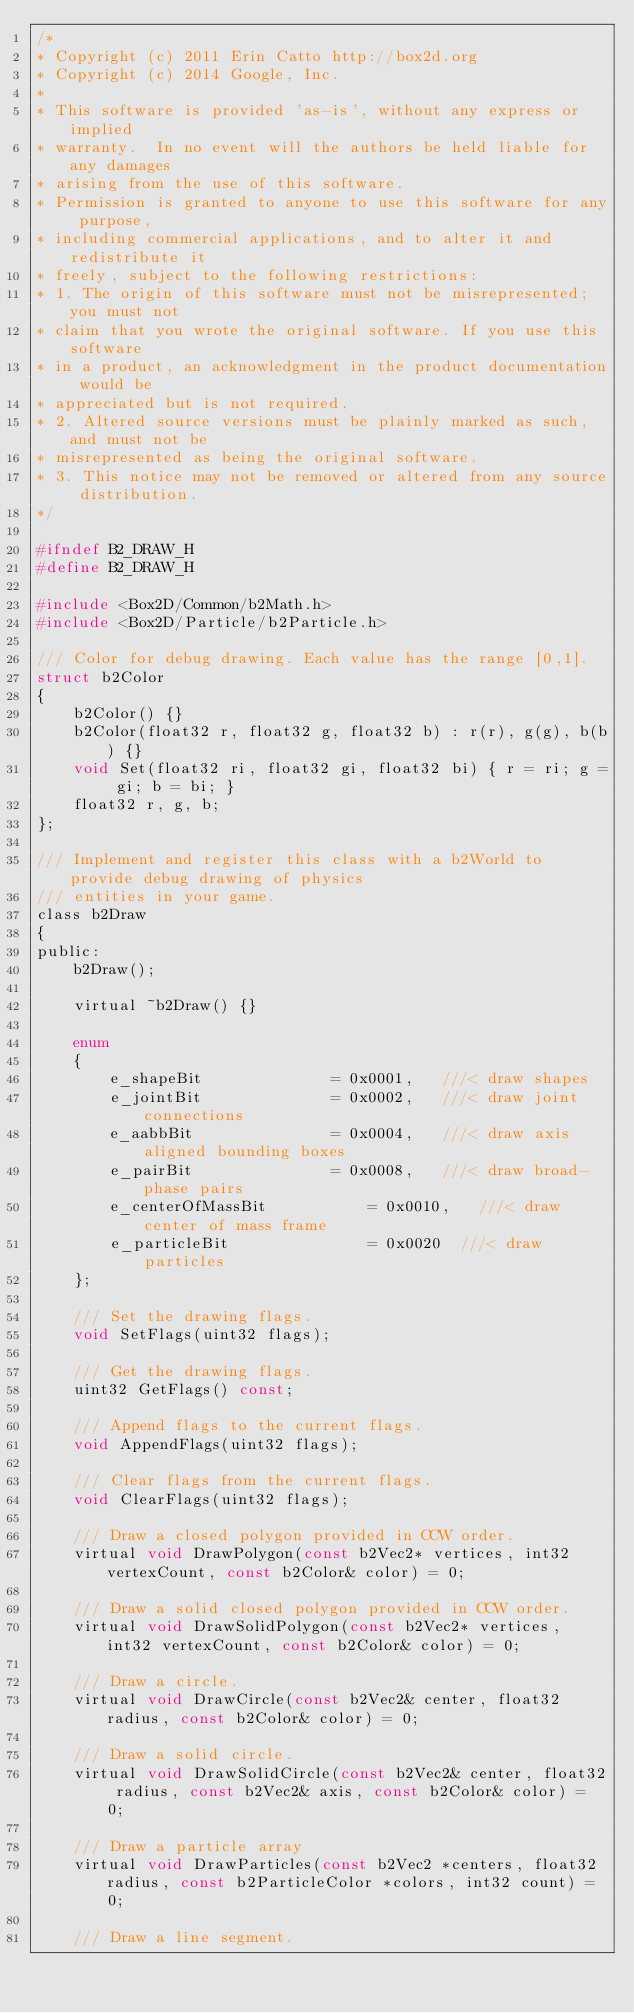Convert code to text. <code><loc_0><loc_0><loc_500><loc_500><_C_>/*
* Copyright (c) 2011 Erin Catto http://box2d.org
* Copyright (c) 2014 Google, Inc.
*
* This software is provided 'as-is', without any express or implied
* warranty.  In no event will the authors be held liable for any damages
* arising from the use of this software.
* Permission is granted to anyone to use this software for any purpose,
* including commercial applications, and to alter it and redistribute it
* freely, subject to the following restrictions:
* 1. The origin of this software must not be misrepresented; you must not
* claim that you wrote the original software. If you use this software
* in a product, an acknowledgment in the product documentation would be
* appreciated but is not required.
* 2. Altered source versions must be plainly marked as such, and must not be
* misrepresented as being the original software.
* 3. This notice may not be removed or altered from any source distribution.
*/

#ifndef B2_DRAW_H
#define B2_DRAW_H

#include <Box2D/Common/b2Math.h>
#include <Box2D/Particle/b2Particle.h>

/// Color for debug drawing. Each value has the range [0,1].
struct b2Color
{
	b2Color() {}
	b2Color(float32 r, float32 g, float32 b) : r(r), g(g), b(b) {}
	void Set(float32 ri, float32 gi, float32 bi) { r = ri; g = gi; b = bi; }
	float32 r, g, b;
};

/// Implement and register this class with a b2World to provide debug drawing of physics
/// entities in your game.
class b2Draw
{
public:
	b2Draw();

	virtual ~b2Draw() {}

	enum
	{
		e_shapeBit				= 0x0001,	///< draw shapes
		e_jointBit				= 0x0002,	///< draw joint connections
		e_aabbBit				= 0x0004,	///< draw axis aligned bounding boxes
		e_pairBit				= 0x0008,	///< draw broad-phase pairs
		e_centerOfMassBit			= 0x0010,	///< draw center of mass frame
		e_particleBit				= 0x0020  ///< draw particles
	};

	/// Set the drawing flags.
	void SetFlags(uint32 flags);

	/// Get the drawing flags.
	uint32 GetFlags() const;

	/// Append flags to the current flags.
	void AppendFlags(uint32 flags);

	/// Clear flags from the current flags.
	void ClearFlags(uint32 flags);

	/// Draw a closed polygon provided in CCW order.
	virtual void DrawPolygon(const b2Vec2* vertices, int32 vertexCount, const b2Color& color) = 0;

	/// Draw a solid closed polygon provided in CCW order.
	virtual void DrawSolidPolygon(const b2Vec2* vertices, int32 vertexCount, const b2Color& color) = 0;

	/// Draw a circle.
	virtual void DrawCircle(const b2Vec2& center, float32 radius, const b2Color& color) = 0;

	/// Draw a solid circle.
	virtual void DrawSolidCircle(const b2Vec2& center, float32 radius, const b2Vec2& axis, const b2Color& color) = 0;

	/// Draw a particle array
	virtual void DrawParticles(const b2Vec2 *centers, float32 radius, const b2ParticleColor *colors, int32 count) = 0;

	/// Draw a line segment.</code> 